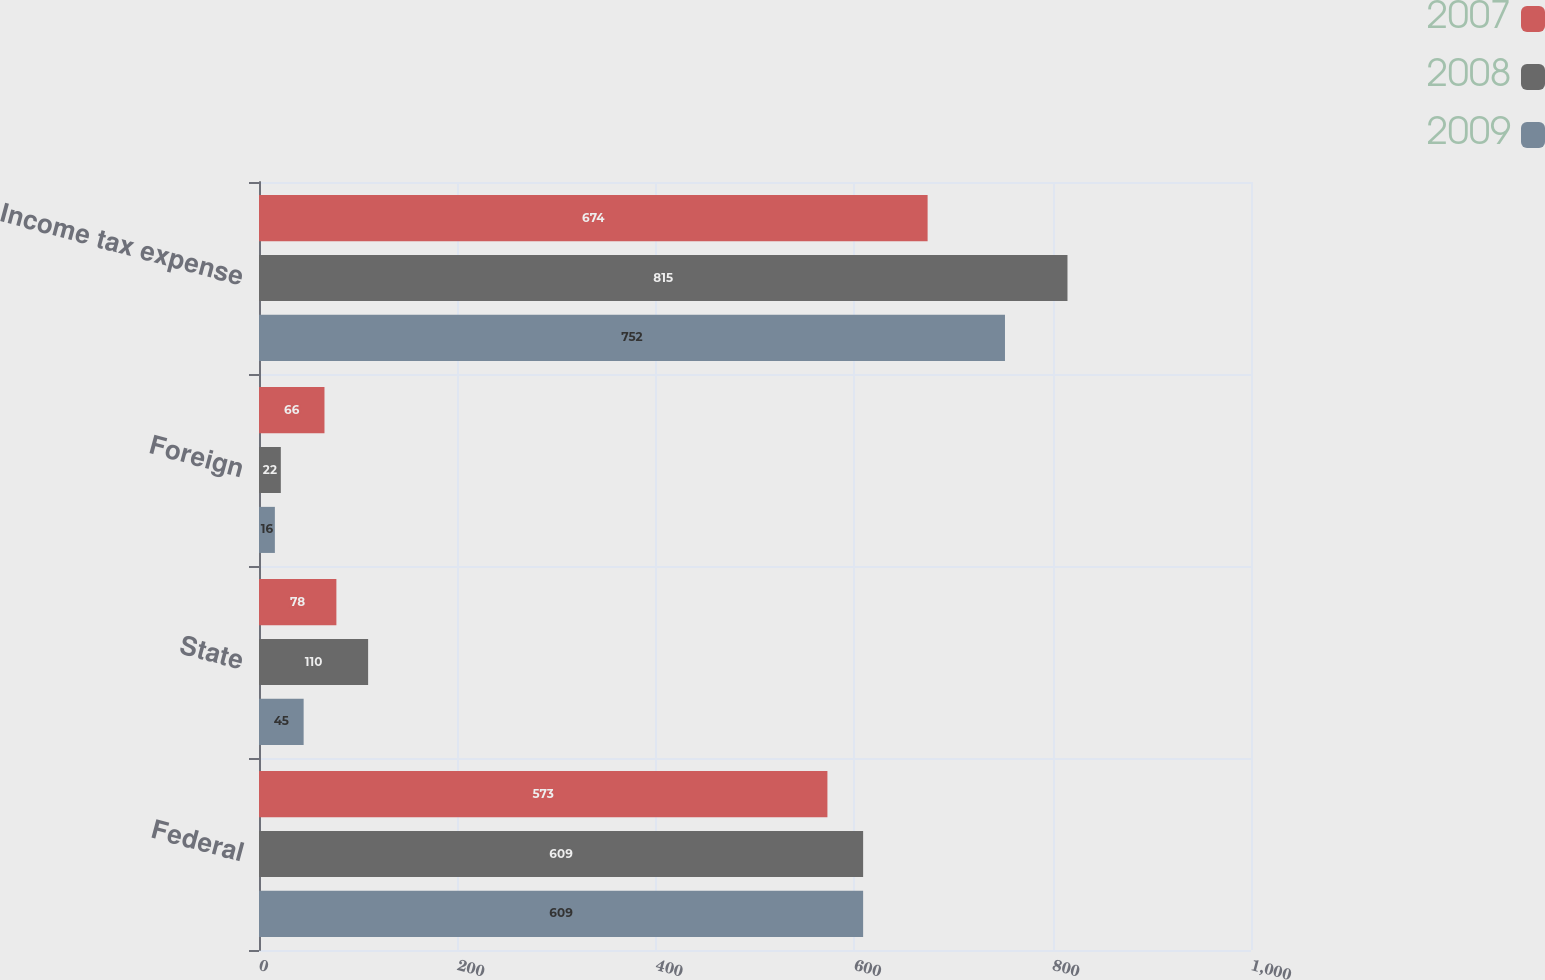<chart> <loc_0><loc_0><loc_500><loc_500><stacked_bar_chart><ecel><fcel>Federal<fcel>State<fcel>Foreign<fcel>Income tax expense<nl><fcel>2007<fcel>573<fcel>78<fcel>66<fcel>674<nl><fcel>2008<fcel>609<fcel>110<fcel>22<fcel>815<nl><fcel>2009<fcel>609<fcel>45<fcel>16<fcel>752<nl></chart> 